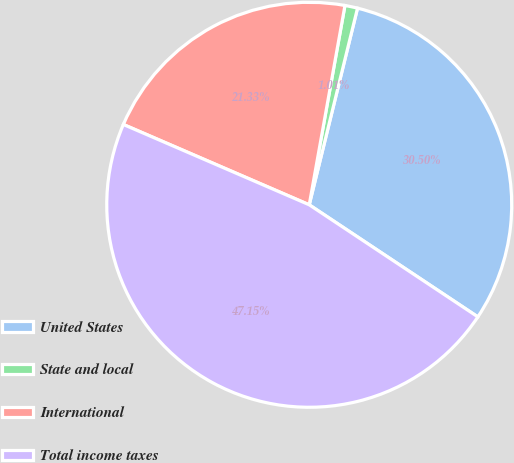<chart> <loc_0><loc_0><loc_500><loc_500><pie_chart><fcel>United States<fcel>State and local<fcel>International<fcel>Total income taxes<nl><fcel>30.5%<fcel>1.01%<fcel>21.33%<fcel>47.15%<nl></chart> 